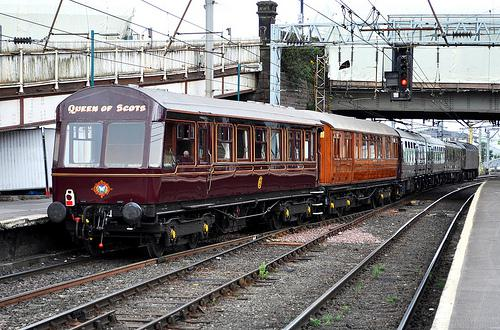Question: what color is the middle train?
Choices:
A. Gold.
B. Black.
C. Red.
D. Gray.
Answer with the letter. Answer: A Question: what colors is the first train?
Choices:
A. Red.
B. Maroon.
C. Yellow.
D. Blue.
Answer with the letter. Answer: B 